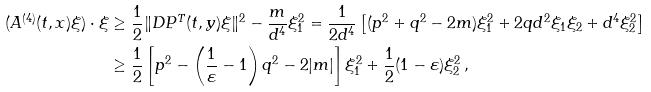<formula> <loc_0><loc_0><loc_500><loc_500>( A ^ { ( 4 ) } ( t , x ) \xi ) \cdot \xi & \geq \frac { 1 } { 2 } \| D P ^ { T } ( t , y ) \xi \| ^ { 2 } - \frac { m } { d ^ { 4 } } \xi _ { 1 } ^ { 2 } = \frac { 1 } { 2 d ^ { 4 } } \left [ ( p ^ { 2 } + q ^ { 2 } - 2 m ) \xi _ { 1 } ^ { 2 } + 2 q d ^ { 2 } \xi _ { 1 } \xi _ { 2 } + d ^ { 4 } \xi _ { 2 } ^ { 2 } \right ] \\ & \geq \frac { 1 } { 2 } \left [ p ^ { 2 } - \left ( \frac { 1 } { \varepsilon } - 1 \right ) q ^ { 2 } - 2 | m | \right ] \xi _ { 1 } ^ { 2 } + \frac { 1 } { 2 } ( 1 - \varepsilon ) \xi _ { 2 } ^ { 2 } \, ,</formula> 